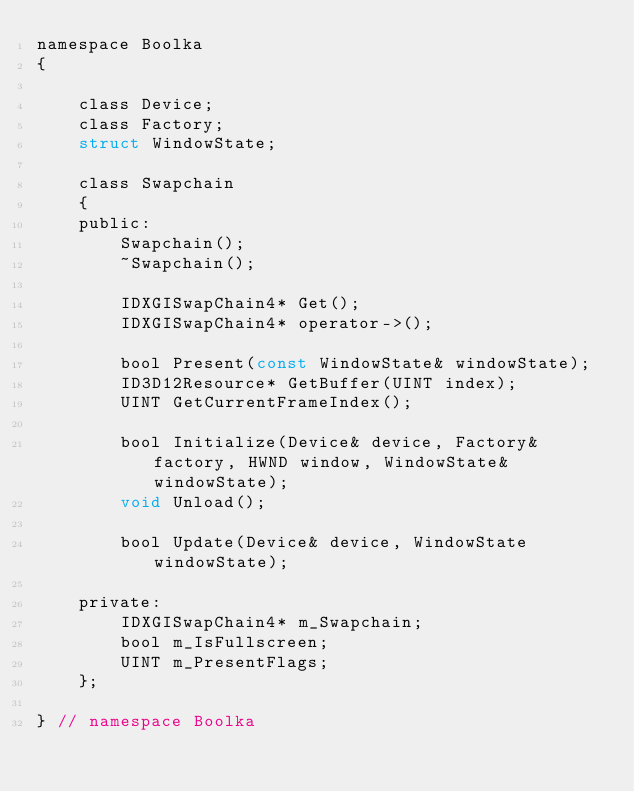<code> <loc_0><loc_0><loc_500><loc_500><_C_>namespace Boolka
{

    class Device;
    class Factory;
    struct WindowState;

    class Swapchain
    {
    public:
        Swapchain();
        ~Swapchain();

        IDXGISwapChain4* Get();
        IDXGISwapChain4* operator->();

        bool Present(const WindowState& windowState);
        ID3D12Resource* GetBuffer(UINT index);
        UINT GetCurrentFrameIndex();

        bool Initialize(Device& device, Factory& factory, HWND window, WindowState& windowState);
        void Unload();

        bool Update(Device& device, WindowState windowState);

    private:
        IDXGISwapChain4* m_Swapchain;
        bool m_IsFullscreen;
        UINT m_PresentFlags;
    };

} // namespace Boolka
</code> 